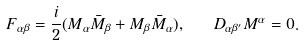<formula> <loc_0><loc_0><loc_500><loc_500>F _ { \alpha \beta } = { \frac { i } { 2 } } ( M _ { \alpha } \bar { M } _ { \beta } + M _ { \beta } \bar { M } _ { \alpha } ) , \quad D _ { \alpha \beta ^ { \prime } } M ^ { \alpha } = 0 .</formula> 